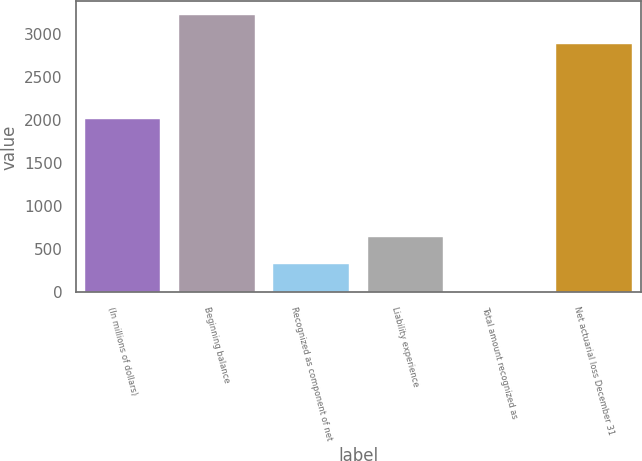<chart> <loc_0><loc_0><loc_500><loc_500><bar_chart><fcel>(In millions of dollars)<fcel>Beginning balance<fcel>Recognized as component of net<fcel>Liability experience<fcel>Total amount recognized as<fcel>Net actuarial loss December 31<nl><fcel>2015<fcel>3215<fcel>326<fcel>647<fcel>5<fcel>2887<nl></chart> 